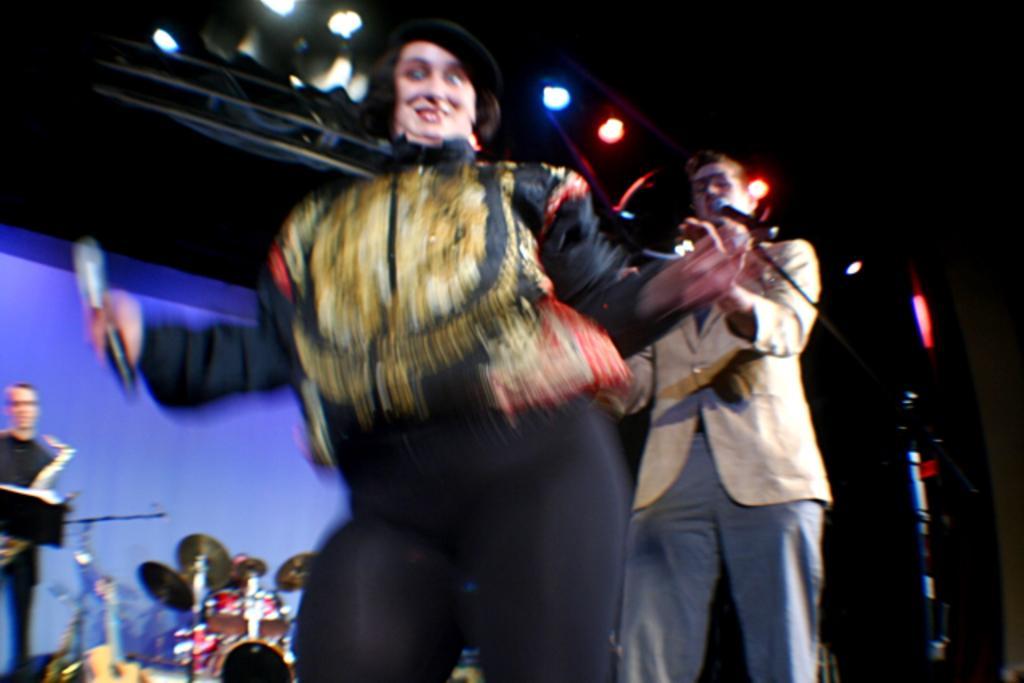How would you summarize this image in a sentence or two? It is a blur image, it looks like there is some event going on and there are few people on the stage and around them there are some musical instruments and to the roof there are different lights. 